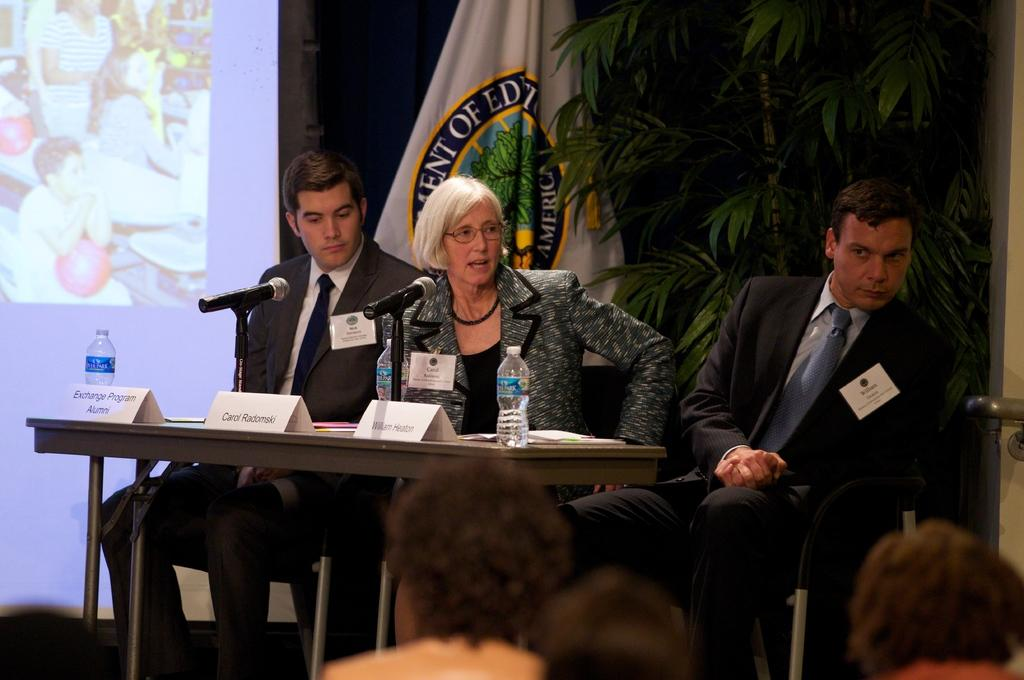What is the main object in the image? There is a screen in the image. What can be seen in the background of the image? There is a tree in the image. What is attached to the tree? There is a flag in the image. How many people are sitting in the image? There are three people sitting on chairs in the image. What is present on the table in the image? There is a table in the image with bottles and microphones (mics) on it. What type of insect is crawling on the screen in the image? There are no insects present on the screen in the image. Are the people sitting on chairs sleeping in the image? The image does not show the people sleeping; they are sitting on chairs. 